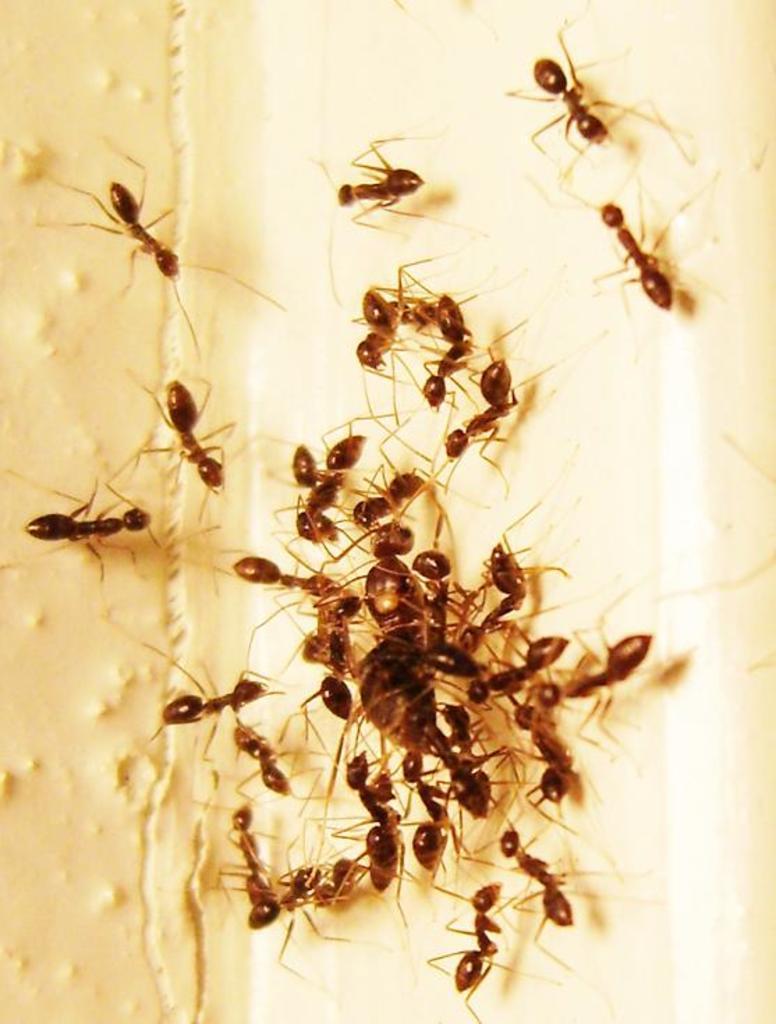How would you summarize this image in a sentence or two? In this image we can see some ants on the surface. 